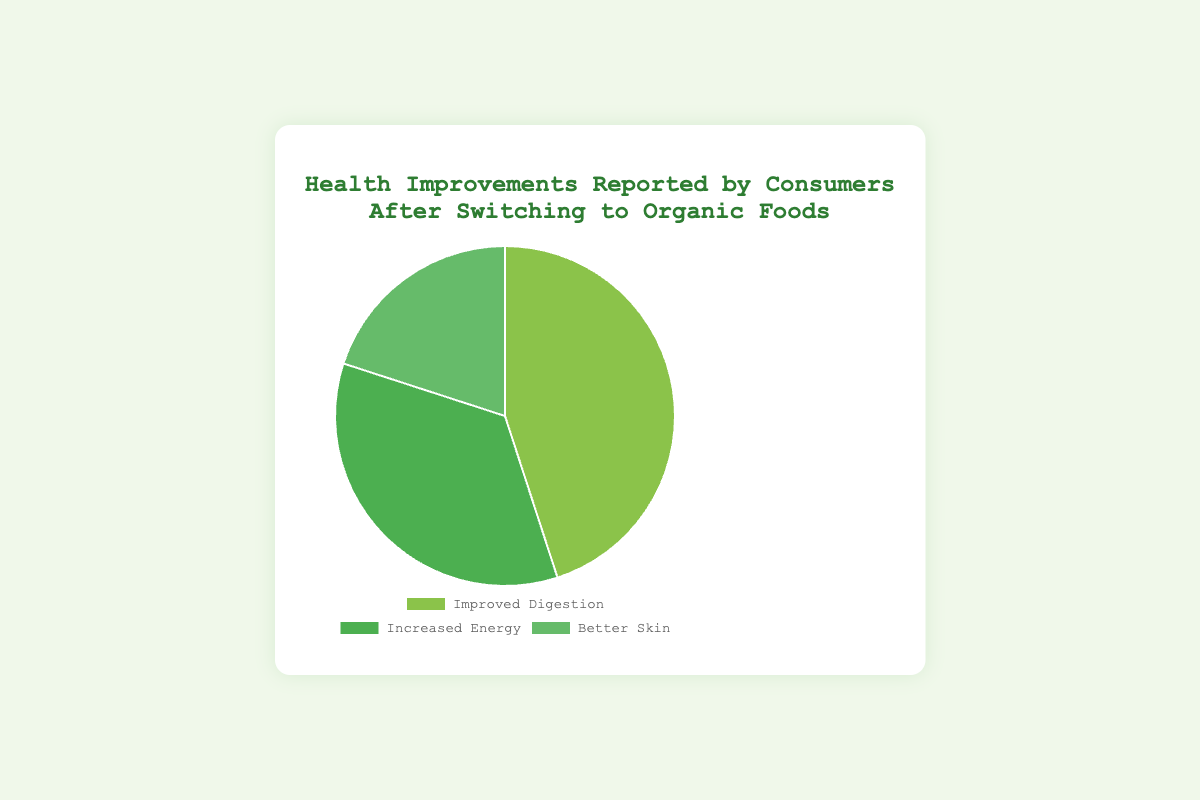Which health improvement is reported by the largest percentage of consumers? The largest segment in the pie chart represents the health improvement with the highest percentage. Improved Digestion takes up the largest portion.
Answer: Improved Digestion Which health improvement is reported by the smallest percentage of consumers? The smallest segment in the pie chart represents the health improvement with the lowest percentage. Better Skin has the smallest portion.
Answer: Better Skin How many more consumers reported Improved Digestion than Increased Energy? Improved Digestion is 45% and Increased Energy is 35%. The difference is 45 - 35.
Answer: 10% What percentage of consumers reported both Increased Energy and Better Skin together? Increased Energy is 35% and Better Skin is 20%. The combined percentage is 35 + 20.
Answer: 55% Which health improvement is represented by the darkest green color? The visual attribute looking at the color representations, the darkest green corresponds to Increased Energy.
Answer: Increased Energy How much more popular is Improved Digestion compared to Better Skin? Improved Digestion is 45% and Better Skin is 20%. The difference is 45 - 20.
Answer: 25% Which two health improvements together make up less than half of the total responses? Increased Energy is 35% and Better Skin is 20%. Their combined total is 35 + 20, which is less than 50%.
Answer: Increased Energy and Better Skin What is the average percentage reported for all three health improvements? Sum the percentages: 45 + 35 + 20 = 100. Then divide by 3 to get the average. 100 / 3 ≈ 33.33
Answer: 33.33% If you were to merge the Improved Digestion and Increased Energy categories, what percentage would they represent on the pie chart? Improved Digestion is 45% and Increased Energy is 35%. The combined percentage is 45 + 35.
Answer: 80% If you split Improved Digestion into two equal parts, what percentage would each part be? Improved Digestion is 45%. Splitting this into two equal parts yields 45 / 2.
Answer: 22.5% 